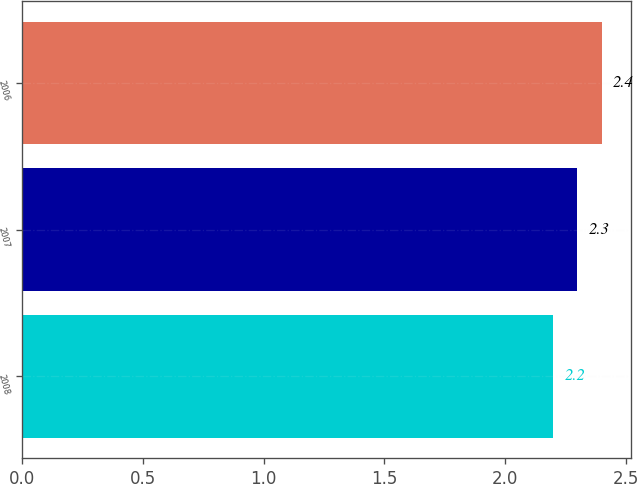<chart> <loc_0><loc_0><loc_500><loc_500><bar_chart><fcel>2008<fcel>2007<fcel>2006<nl><fcel>2.2<fcel>2.3<fcel>2.4<nl></chart> 